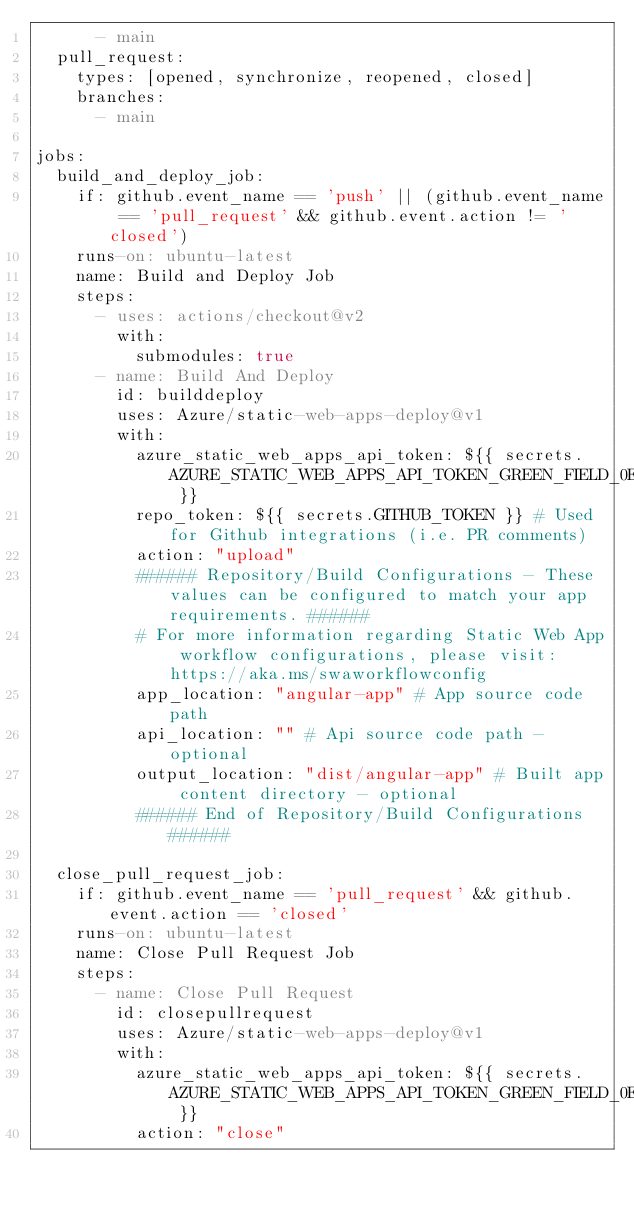Convert code to text. <code><loc_0><loc_0><loc_500><loc_500><_YAML_>      - main
  pull_request:
    types: [opened, synchronize, reopened, closed]
    branches:
      - main

jobs:
  build_and_deploy_job:
    if: github.event_name == 'push' || (github.event_name == 'pull_request' && github.event.action != 'closed')
    runs-on: ubuntu-latest
    name: Build and Deploy Job
    steps:
      - uses: actions/checkout@v2
        with:
          submodules: true
      - name: Build And Deploy
        id: builddeploy
        uses: Azure/static-web-apps-deploy@v1
        with:
          azure_static_web_apps_api_token: ${{ secrets.AZURE_STATIC_WEB_APPS_API_TOKEN_GREEN_FIELD_0ED9D6E00 }}
          repo_token: ${{ secrets.GITHUB_TOKEN }} # Used for Github integrations (i.e. PR comments)
          action: "upload"
          ###### Repository/Build Configurations - These values can be configured to match your app requirements. ######
          # For more information regarding Static Web App workflow configurations, please visit: https://aka.ms/swaworkflowconfig
          app_location: "angular-app" # App source code path
          api_location: "" # Api source code path - optional
          output_location: "dist/angular-app" # Built app content directory - optional
          ###### End of Repository/Build Configurations ######

  close_pull_request_job:
    if: github.event_name == 'pull_request' && github.event.action == 'closed'
    runs-on: ubuntu-latest
    name: Close Pull Request Job
    steps:
      - name: Close Pull Request
        id: closepullrequest
        uses: Azure/static-web-apps-deploy@v1
        with:
          azure_static_web_apps_api_token: ${{ secrets.AZURE_STATIC_WEB_APPS_API_TOKEN_GREEN_FIELD_0ED9D6E00 }}
          action: "close"
</code> 